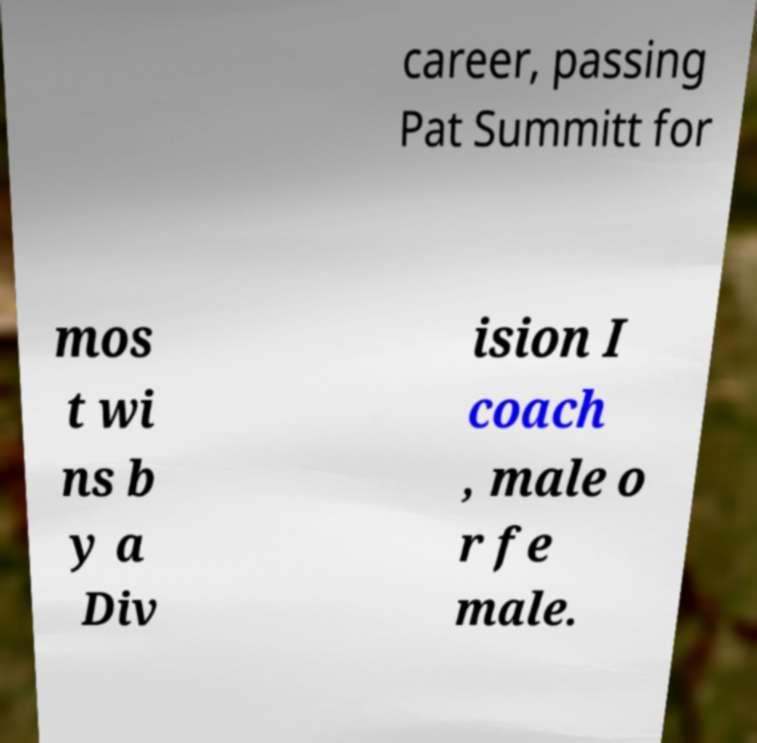Could you extract and type out the text from this image? career, passing Pat Summitt for mos t wi ns b y a Div ision I coach , male o r fe male. 